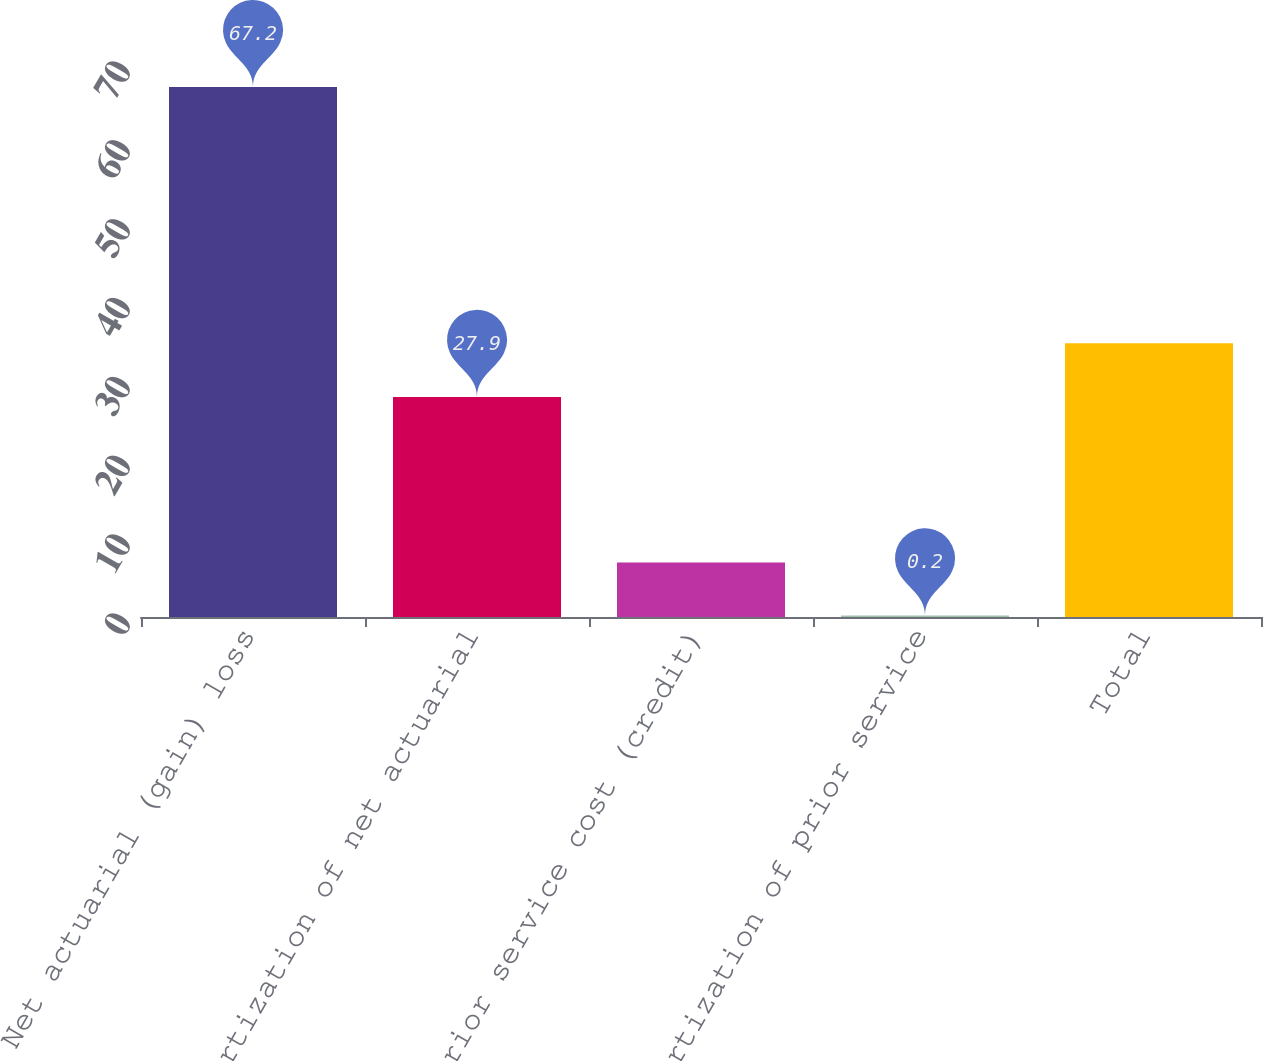Convert chart to OTSL. <chart><loc_0><loc_0><loc_500><loc_500><bar_chart><fcel>Net actuarial (gain) loss<fcel>Amortization of net actuarial<fcel>Prior service cost (credit)<fcel>Amortization of prior service<fcel>Total<nl><fcel>67.2<fcel>27.9<fcel>6.9<fcel>0.2<fcel>34.7<nl></chart> 